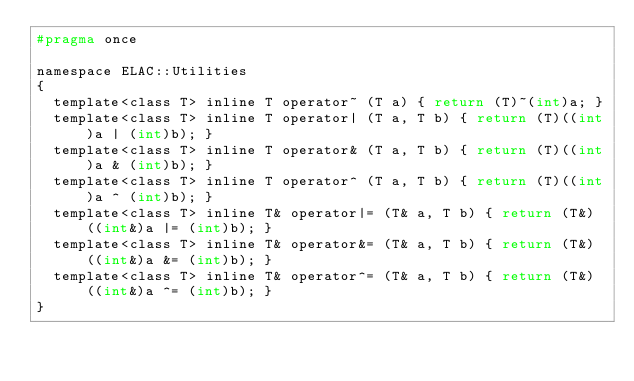<code> <loc_0><loc_0><loc_500><loc_500><_C_>#pragma once

namespace ELAC::Utilities
{
	template<class T> inline T operator~ (T a) { return (T)~(int)a; }
	template<class T> inline T operator| (T a, T b) { return (T)((int)a | (int)b); }
	template<class T> inline T operator& (T a, T b) { return (T)((int)a & (int)b); }
	template<class T> inline T operator^ (T a, T b) { return (T)((int)a ^ (int)b); }
	template<class T> inline T& operator|= (T& a, T b) { return (T&)((int&)a |= (int)b); }
	template<class T> inline T& operator&= (T& a, T b) { return (T&)((int&)a &= (int)b); }
	template<class T> inline T& operator^= (T& a, T b) { return (T&)((int&)a ^= (int)b); }
}</code> 